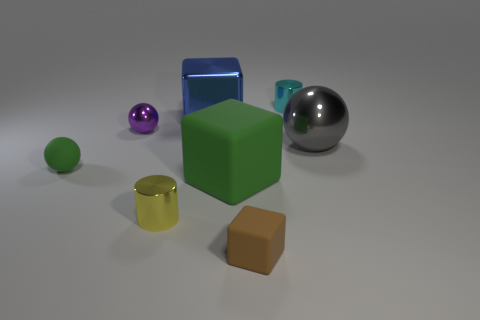Add 1 tiny gray rubber blocks. How many objects exist? 9 Subtract all cubes. How many objects are left? 5 Subtract all small green rubber balls. Subtract all big green matte objects. How many objects are left? 6 Add 7 small yellow things. How many small yellow things are left? 8 Add 7 small purple rubber spheres. How many small purple rubber spheres exist? 7 Subtract 1 green cubes. How many objects are left? 7 